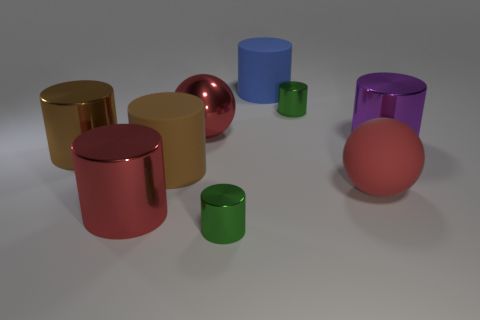Is the number of blue cylinders in front of the large matte sphere less than the number of tiny blue metallic objects?
Your answer should be compact. No. There is a tiny green shiny thing in front of the large red metal cylinder; is its shape the same as the blue rubber object?
Give a very brief answer. Yes. Is there any other thing that has the same color as the big shiny sphere?
Provide a succinct answer. Yes. What size is the cylinder that is made of the same material as the blue thing?
Offer a terse response. Large. There is a large cylinder in front of the big brown thing that is to the right of the big shiny cylinder in front of the large red rubber ball; what is its material?
Keep it short and to the point. Metal. Is the number of shiny objects less than the number of cylinders?
Provide a short and direct response. Yes. Is the purple cylinder made of the same material as the big red cylinder?
Make the answer very short. Yes. What shape is the matte thing that is the same color as the large metal sphere?
Your answer should be compact. Sphere. Do the large sphere behind the purple thing and the big matte sphere have the same color?
Give a very brief answer. Yes. How many big brown objects are to the right of the big sphere to the left of the large red matte thing?
Ensure brevity in your answer.  0. 